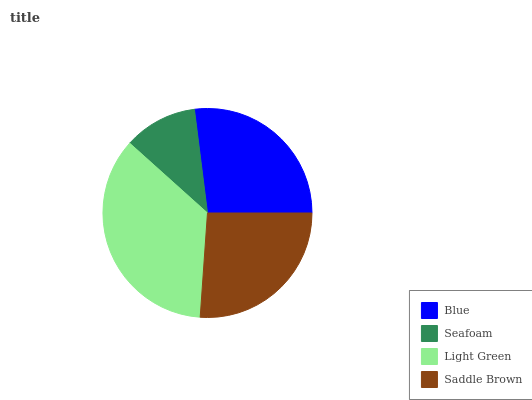Is Seafoam the minimum?
Answer yes or no. Yes. Is Light Green the maximum?
Answer yes or no. Yes. Is Light Green the minimum?
Answer yes or no. No. Is Seafoam the maximum?
Answer yes or no. No. Is Light Green greater than Seafoam?
Answer yes or no. Yes. Is Seafoam less than Light Green?
Answer yes or no. Yes. Is Seafoam greater than Light Green?
Answer yes or no. No. Is Light Green less than Seafoam?
Answer yes or no. No. Is Blue the high median?
Answer yes or no. Yes. Is Saddle Brown the low median?
Answer yes or no. Yes. Is Saddle Brown the high median?
Answer yes or no. No. Is Light Green the low median?
Answer yes or no. No. 